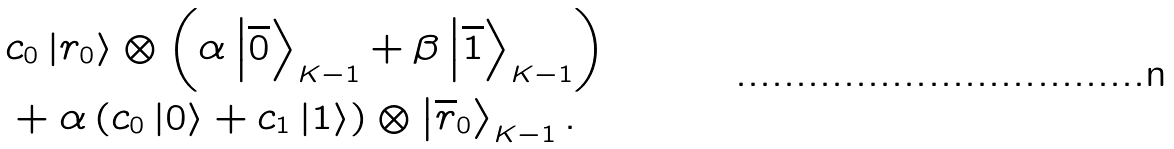<formula> <loc_0><loc_0><loc_500><loc_500>& c _ { 0 } \left | r _ { 0 } \right \rangle \otimes \left ( \alpha \left | \overline { 0 } \right \rangle _ { K - 1 } + \beta \left | \overline { 1 } \right \rangle _ { K - 1 } \right ) \\ & + \alpha \left ( c _ { 0 } \left | 0 \right \rangle + c _ { 1 } \left | 1 \right \rangle \right ) \otimes \left | \overline { r } _ { 0 } \right \rangle _ { K - 1 } .</formula> 